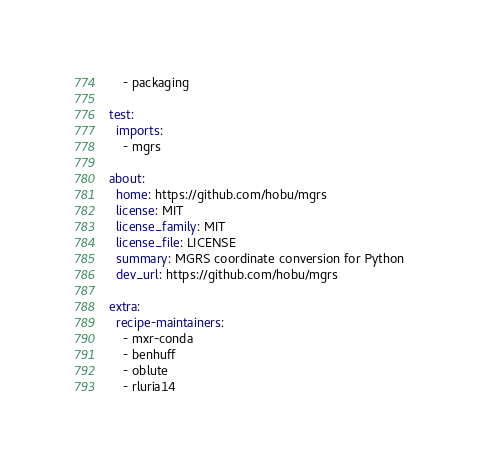<code> <loc_0><loc_0><loc_500><loc_500><_YAML_>    - packaging

test:
  imports:
    - mgrs

about:
  home: https://github.com/hobu/mgrs
  license: MIT
  license_family: MIT
  license_file: LICENSE
  summary: MGRS coordinate conversion for Python
  dev_url: https://github.com/hobu/mgrs

extra:
  recipe-maintainers:
    - mxr-conda
    - benhuff
    - oblute
    - rluria14
</code> 